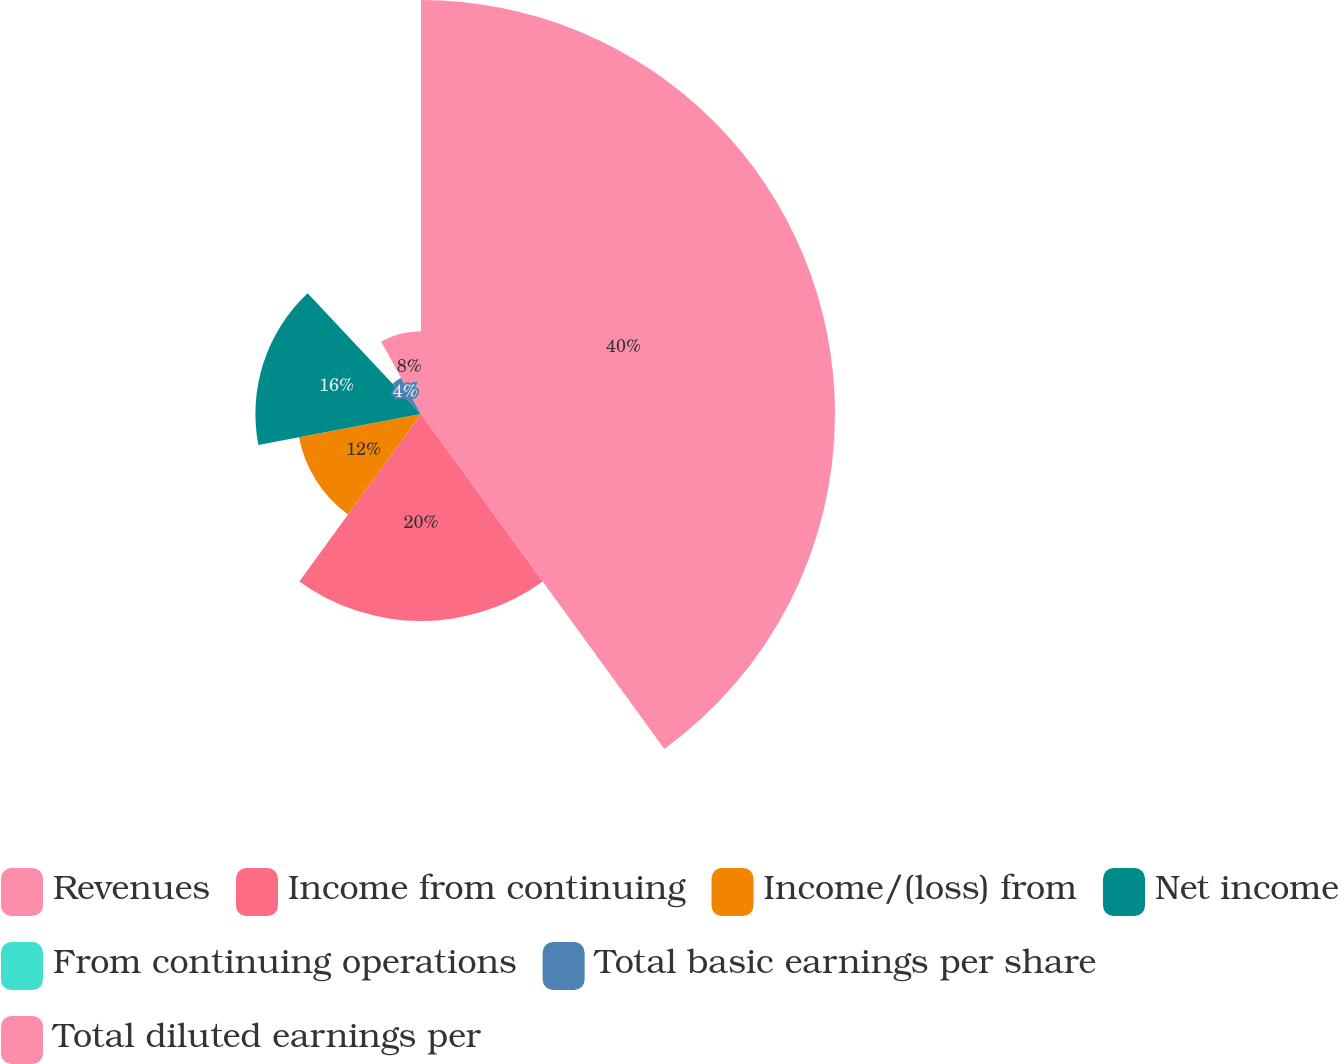<chart> <loc_0><loc_0><loc_500><loc_500><pie_chart><fcel>Revenues<fcel>Income from continuing<fcel>Income/(loss) from<fcel>Net income<fcel>From continuing operations<fcel>Total basic earnings per share<fcel>Total diluted earnings per<nl><fcel>40.0%<fcel>20.0%<fcel>12.0%<fcel>16.0%<fcel>0.0%<fcel>4.0%<fcel>8.0%<nl></chart> 